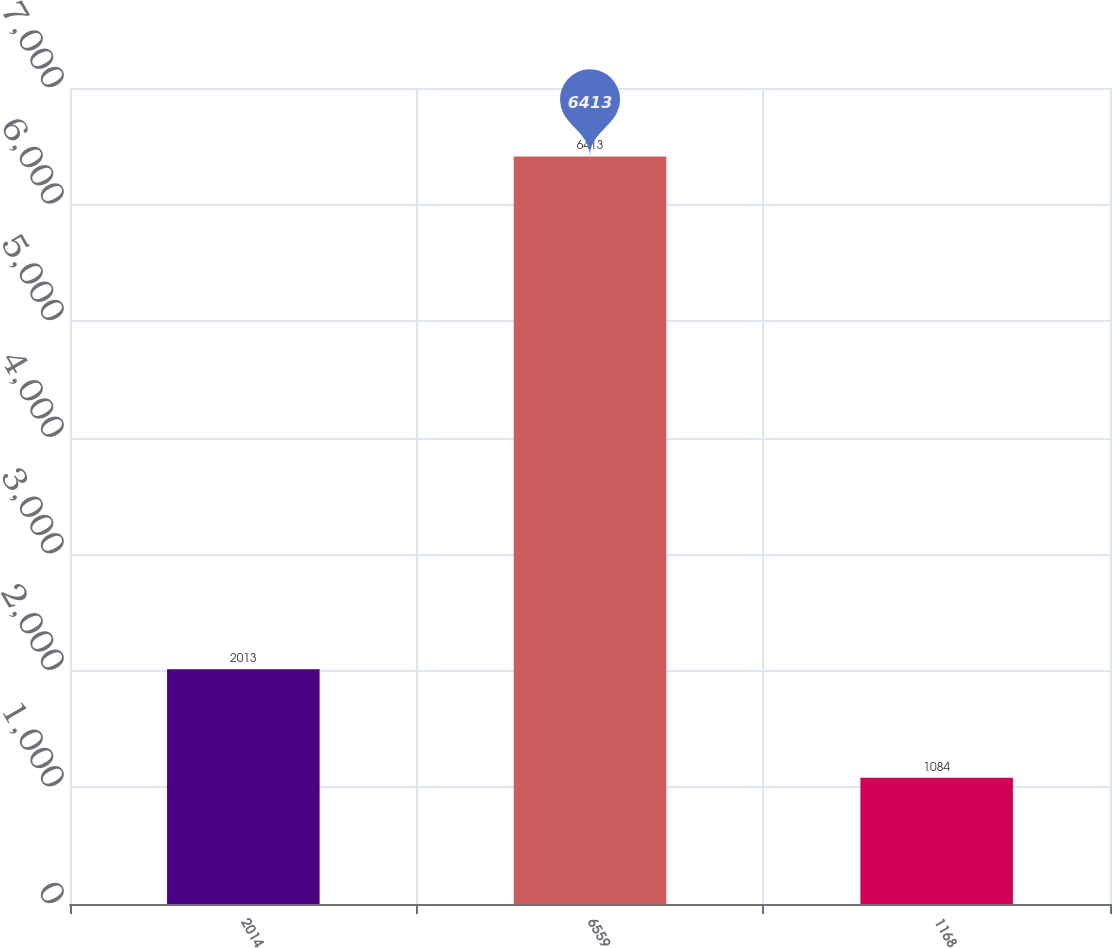Convert chart to OTSL. <chart><loc_0><loc_0><loc_500><loc_500><bar_chart><fcel>2014<fcel>6559<fcel>1168<nl><fcel>2013<fcel>6413<fcel>1084<nl></chart> 